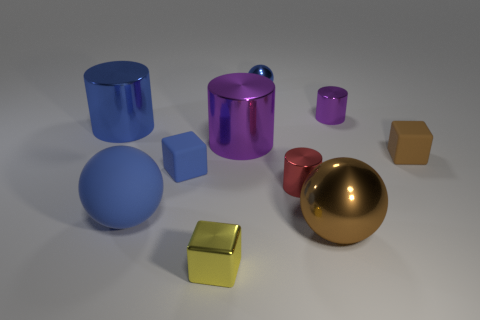Subtract all tiny metal blocks. How many blocks are left? 2 Subtract all brown spheres. How many spheres are left? 2 Subtract all spheres. How many objects are left? 7 Subtract 1 blocks. How many blocks are left? 2 Subtract all yellow spheres. Subtract all gray cubes. How many spheres are left? 3 Subtract all brown balls. How many purple cubes are left? 0 Subtract all small blue objects. Subtract all blue rubber spheres. How many objects are left? 7 Add 9 tiny spheres. How many tiny spheres are left? 10 Add 5 brown spheres. How many brown spheres exist? 6 Subtract 0 cyan cylinders. How many objects are left? 10 